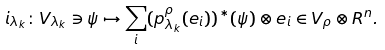Convert formula to latex. <formula><loc_0><loc_0><loc_500><loc_500>i _ { \lambda _ { k } } \colon V _ { \lambda _ { k } } \ni \psi \mapsto \sum _ { i } ( p _ { \lambda _ { k } } ^ { \rho } ( e _ { i } ) ) ^ { \ast } ( \psi ) \otimes e _ { i } \in V _ { \rho } \otimes R ^ { n } .</formula> 